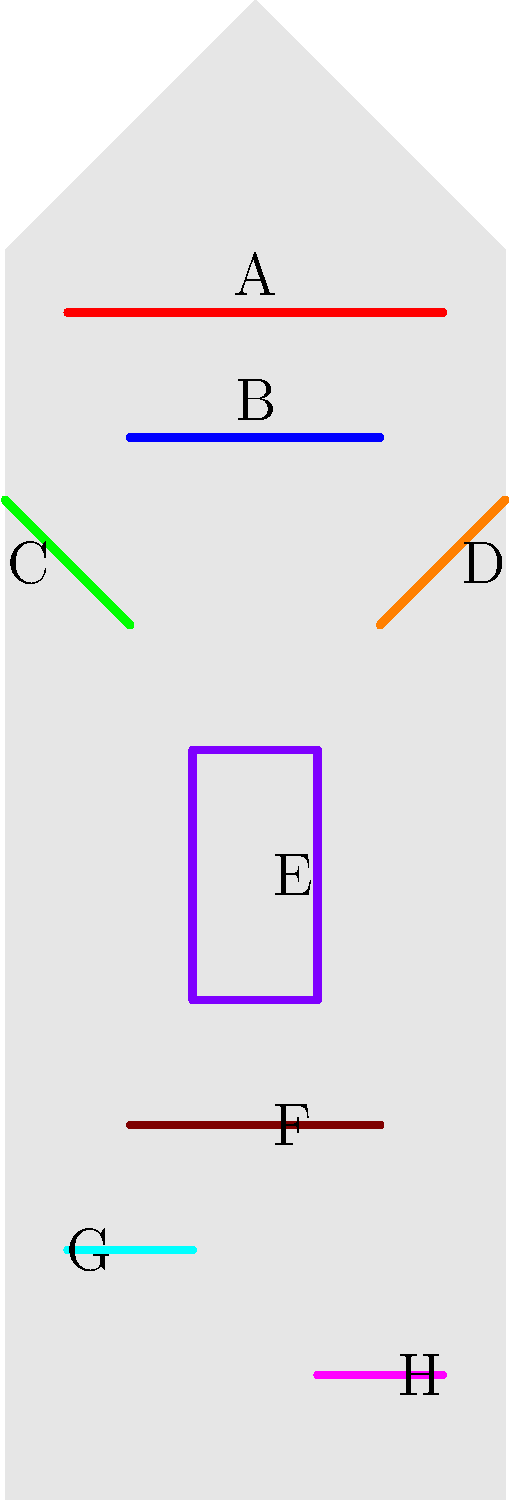As a health-conscious individual in your 50s, you're interested in optimizing your workout routine. The diagram shows different muscle groups labeled A through H. Which combination of exercises would most effectively target muscle groups A, B, and E for a balanced upper body workout, considering the need for joint-friendly options suitable for your age group?

1. Push-ups, Lat pull-downs, and Planks
2. Shoulder press, Bench press, and Russian twists
3. Rowing, Chest flyes, and Crunches
4. Lateral raises, Incline bench press, and Stability ball crunches To answer this question, we need to identify the muscle groups and consider age-appropriate exercises:

1. Identify the muscle groups:
   A: Shoulders (Deltoids)
   B: Chest (Pectorals)
   E: Abdominals

2. Consider joint-friendly exercises for each muscle group:
   Shoulders: Lateral raises are gentler on the shoulder joints than overhead presses.
   Chest: Incline bench press targets the upper chest and is often more comfortable for older adults than flat bench press.
   Abdominals: Stability ball crunches provide back support and are easier on the spine than traditional crunches.

3. Evaluate each option:
   1. Push-ups (targets B), Lat pull-downs (targets back, not A, B, or E), Planks (targets E)
   2. Shoulder press (targets A but may stress joints), Bench press (targets B), Russian twists (targets E but may strain lower back)
   3. Rowing (targets back, not A, B, or E), Chest flyes (targets B), Crunches (targets E but may strain neck and back)
   4. Lateral raises (targets A), Incline bench press (targets B), Stability ball crunches (targets E)

4. Choose the most effective and joint-friendly combination:
   Option 4 provides the best balance of targeting the specified muscle groups (A, B, and E) while considering joint health for individuals in their 50s.
Answer: 4. Lateral raises, Incline bench press, and Stability ball crunches 